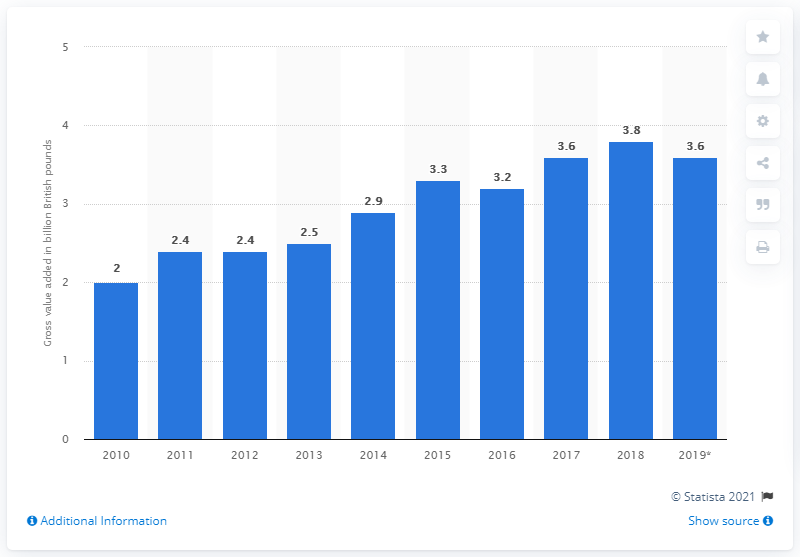Mention a couple of crucial points in this snapshot. The gross value added of the architecture industry in 2019 was approximately 3.6 billion U.S. dollars. 